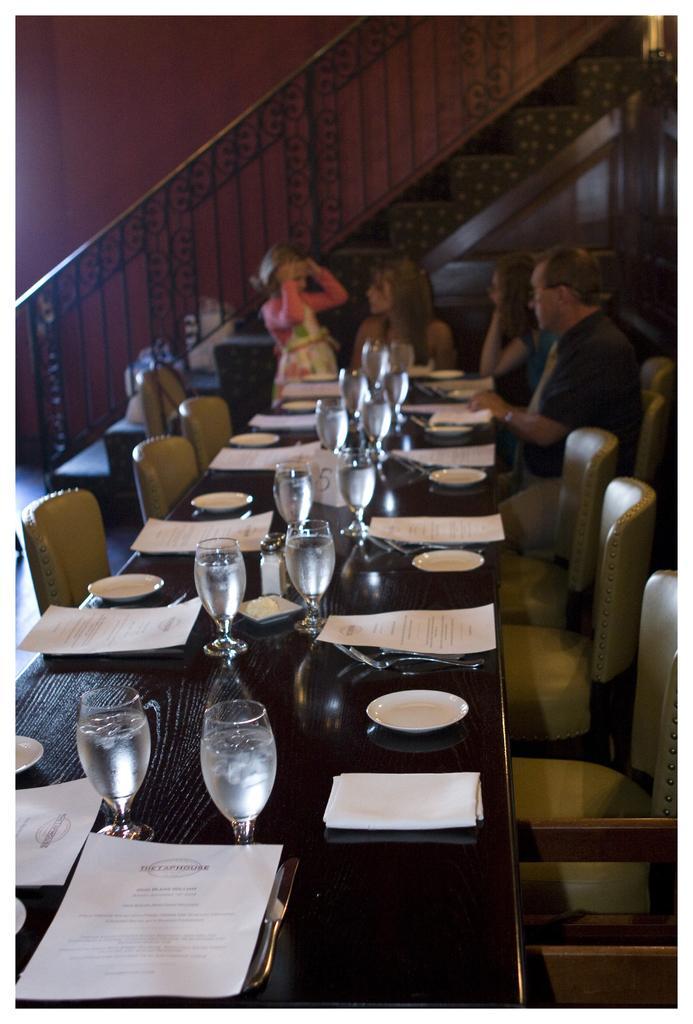How would you summarize this image in a sentence or two? In this picture we can see some persons are sitting on the chairs. This is table. On the table there are glasses, plates, and papers. On the background there is a wall. 